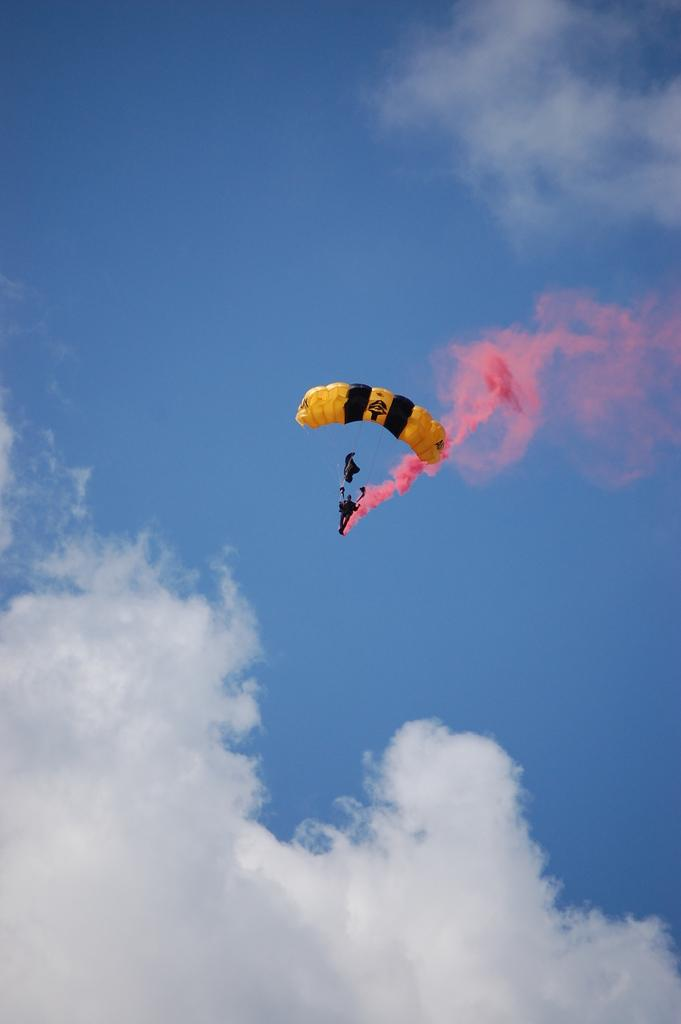What is floating in the air in the image? There is a parachute in the air. What can be seen in the sky in the image? There are clouds visible in the image. How does the baby's stomach feel in the image? There is no baby present in the image, so it is not possible to determine how the baby's stomach feels. 